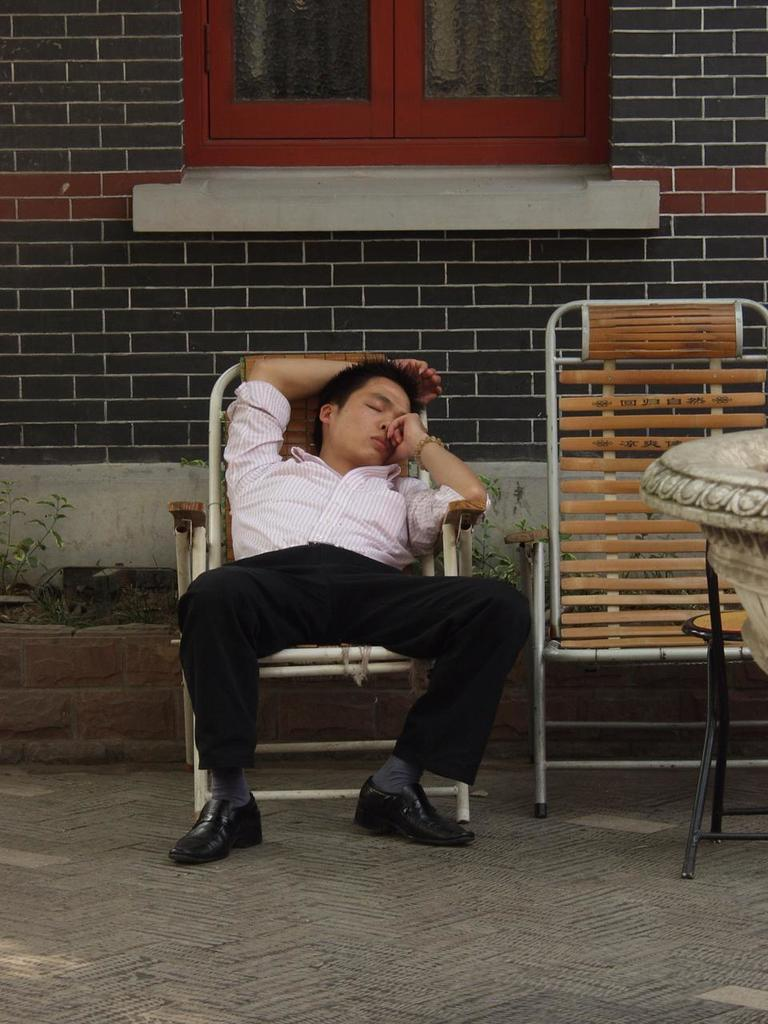What is the man in the image doing? The man is sleeping in a chair. What can be seen beside the sleeping man? There is an empty chair beside the sleeping man. What is visible in the background of the image? There is a wall in the background of the image. Can you describe the wall in the image? There is a window in the wall. What type of songs can be heard coming from the garden in the image? There is no garden present in the image, so it's not possible to determine what, if any, songs might be heard. 